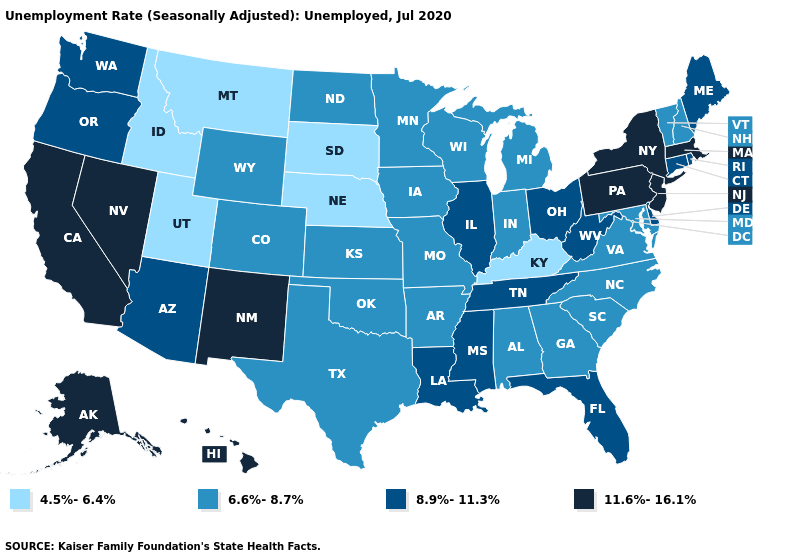What is the value of Florida?
Concise answer only. 8.9%-11.3%. What is the value of Wisconsin?
Quick response, please. 6.6%-8.7%. Which states have the highest value in the USA?
Short answer required. Alaska, California, Hawaii, Massachusetts, Nevada, New Jersey, New Mexico, New York, Pennsylvania. Does Nebraska have the lowest value in the MidWest?
Concise answer only. Yes. What is the highest value in the South ?
Write a very short answer. 8.9%-11.3%. What is the value of Louisiana?
Concise answer only. 8.9%-11.3%. Does Georgia have the highest value in the South?
Short answer required. No. Which states have the lowest value in the MidWest?
Be succinct. Nebraska, South Dakota. Does Nebraska have the lowest value in the MidWest?
Write a very short answer. Yes. Name the states that have a value in the range 8.9%-11.3%?
Be succinct. Arizona, Connecticut, Delaware, Florida, Illinois, Louisiana, Maine, Mississippi, Ohio, Oregon, Rhode Island, Tennessee, Washington, West Virginia. Is the legend a continuous bar?
Be succinct. No. Does the first symbol in the legend represent the smallest category?
Quick response, please. Yes. What is the highest value in the South ?
Concise answer only. 8.9%-11.3%. Name the states that have a value in the range 6.6%-8.7%?
Answer briefly. Alabama, Arkansas, Colorado, Georgia, Indiana, Iowa, Kansas, Maryland, Michigan, Minnesota, Missouri, New Hampshire, North Carolina, North Dakota, Oklahoma, South Carolina, Texas, Vermont, Virginia, Wisconsin, Wyoming. Does the first symbol in the legend represent the smallest category?
Write a very short answer. Yes. 